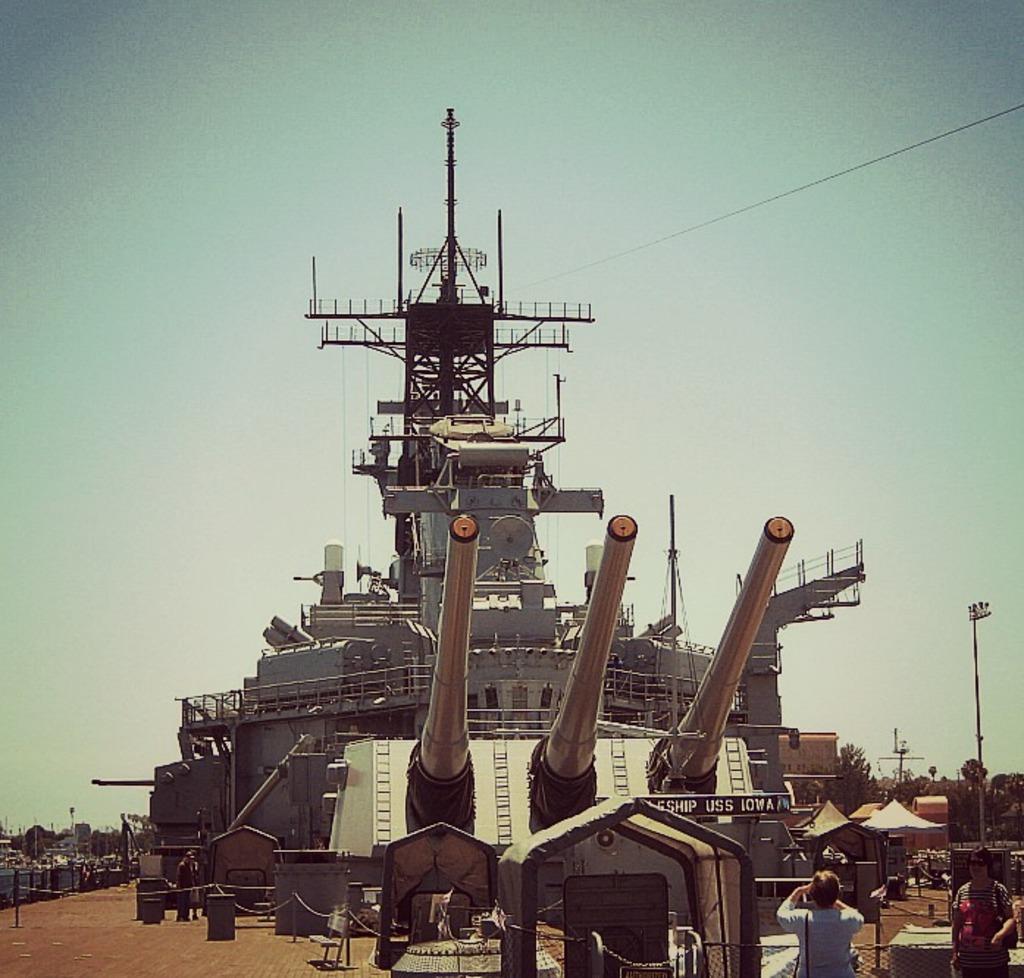Describe this image in one or two sentences. In the picture I can see a ship, cannons, people standing on the ground, fence, poles, wires and some other objects on the ground. In the background I can see trees and the sky. 